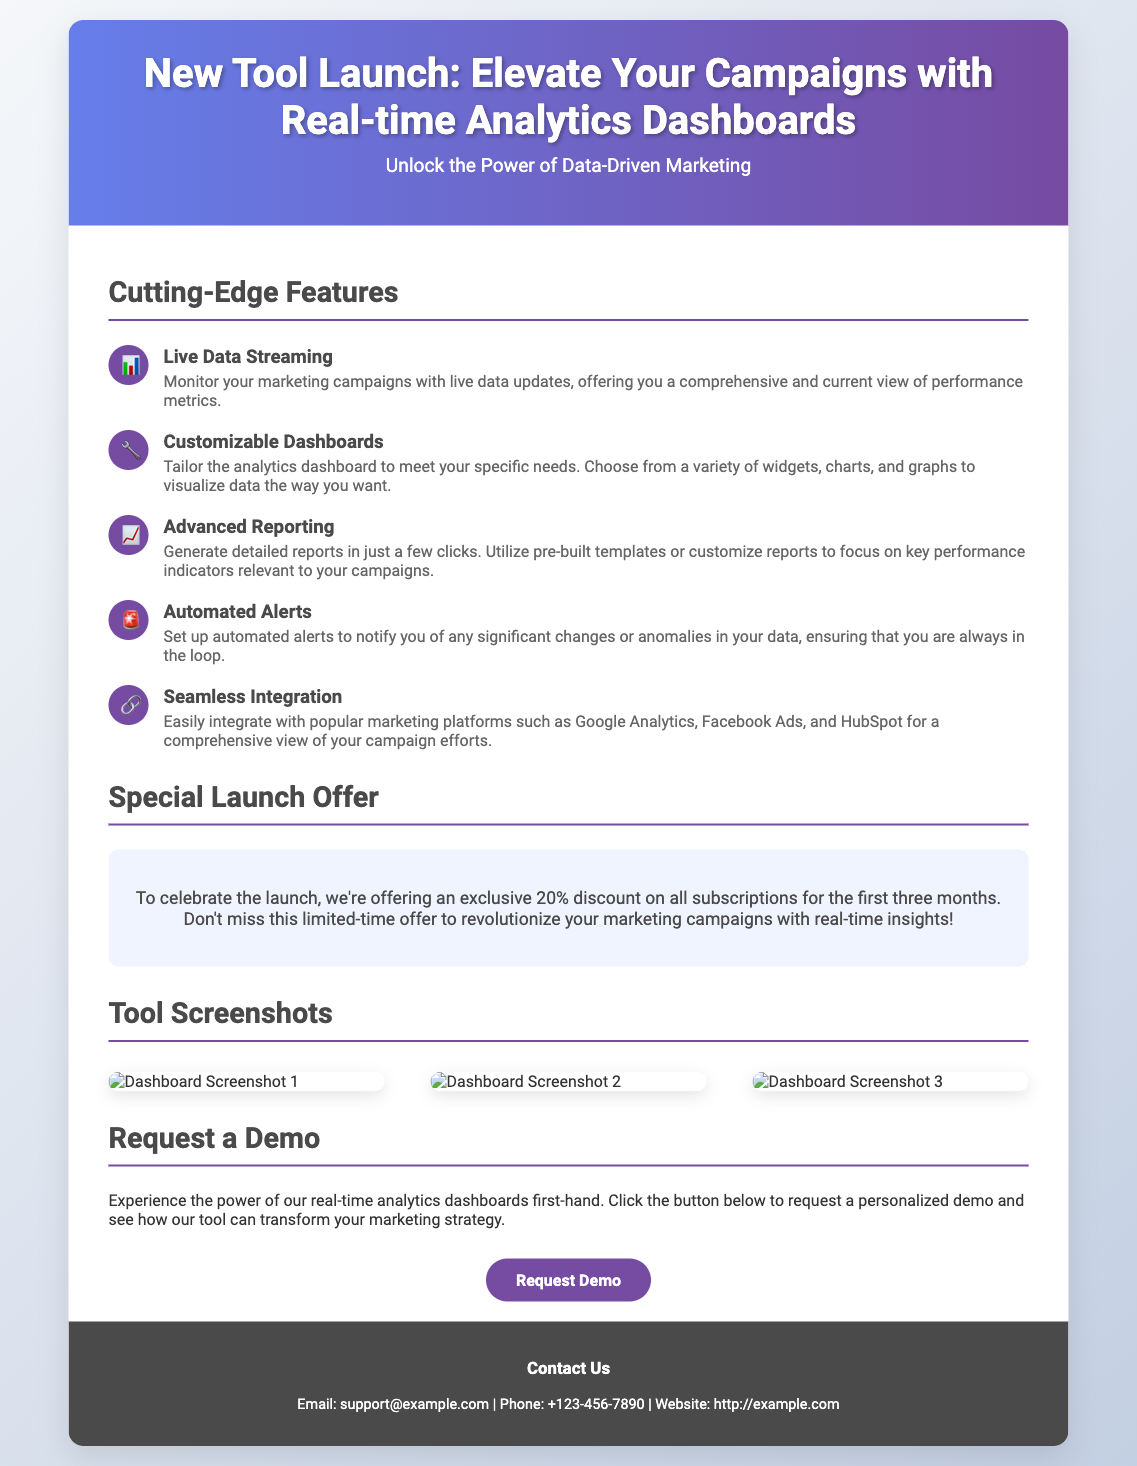What is the title of the flyer? The title is prominently displayed at the top of the document and denotes the main focus of the flyer.
Answer: New Tool Launch: Elevate Your Campaigns with Real-time Analytics Dashboards What is the special launch offer percentage? The offer is detailed in a dedicated section within the flyer and specifies the discount available for new users.
Answer: 20% What feature allows you to monitor marketing campaigns with frequent updates? This feature is mentioned in the "Cutting-Edge Features" section and highlights the real-time capabilities of the tool.
Answer: Live Data Streaming Which platforms does the tool integrate with? The flyer mentions specific platforms under the features section, showing compatibility and ease of use.
Answer: Google Analytics, Facebook Ads, HubSpot What is the main call to action in the flyer? The flyer has a clear directive for the audience on what to do next, specifically highlighted at the end.
Answer: Request Demo How many screenshots are displayed in the tool's section? The design indicates the visual aids included to showcase the tool's interface, providing practical insights.
Answer: 3 What icon represents the customizable dashboards feature? Icons accompany each feature in the document, providing a quick visual reference for understanding.
Answer: 🔧 What is the contact email provided in the footer of the flyer? The footer contains essential contact information for inquiries related to the tool.
Answer: support@example.com 